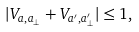Convert formula to latex. <formula><loc_0><loc_0><loc_500><loc_500>| V _ { a , a _ { \perp } } + V _ { a ^ { \prime } , a ^ { \prime } _ { \perp } } | \leq 1 ,</formula> 